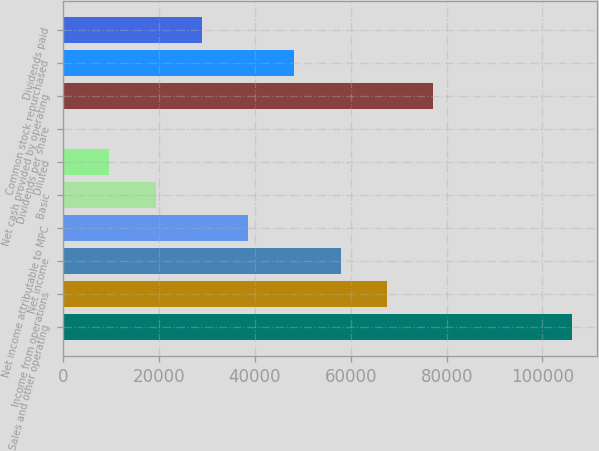Convert chart. <chart><loc_0><loc_0><loc_500><loc_500><bar_chart><fcel>Sales and other operating<fcel>Income from operations<fcel>Net income<fcel>Net income attributable to MPC<fcel>Basic<fcel>Diluted<fcel>Dividends per share<fcel>Net cash provided by operating<fcel>Common stock repurchased<fcel>Dividends paid<nl><fcel>106154<fcel>67553.4<fcel>57903.2<fcel>38602.7<fcel>19302.3<fcel>9652.06<fcel>1.84<fcel>77203.6<fcel>48252.9<fcel>28952.5<nl></chart> 